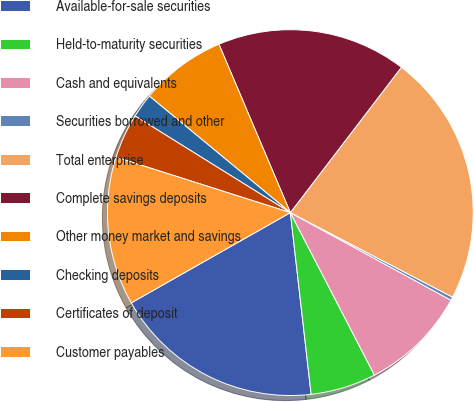Convert chart to OTSL. <chart><loc_0><loc_0><loc_500><loc_500><pie_chart><fcel>Available-for-sale securities<fcel>Held-to-maturity securities<fcel>Cash and equivalents<fcel>Securities borrowed and other<fcel>Total enterprise<fcel>Complete savings deposits<fcel>Other money market and savings<fcel>Checking deposits<fcel>Certificates of deposit<fcel>Customer payables<nl><fcel>18.6%<fcel>5.79%<fcel>9.45%<fcel>0.3%<fcel>22.26%<fcel>16.77%<fcel>7.62%<fcel>2.13%<fcel>3.96%<fcel>13.11%<nl></chart> 